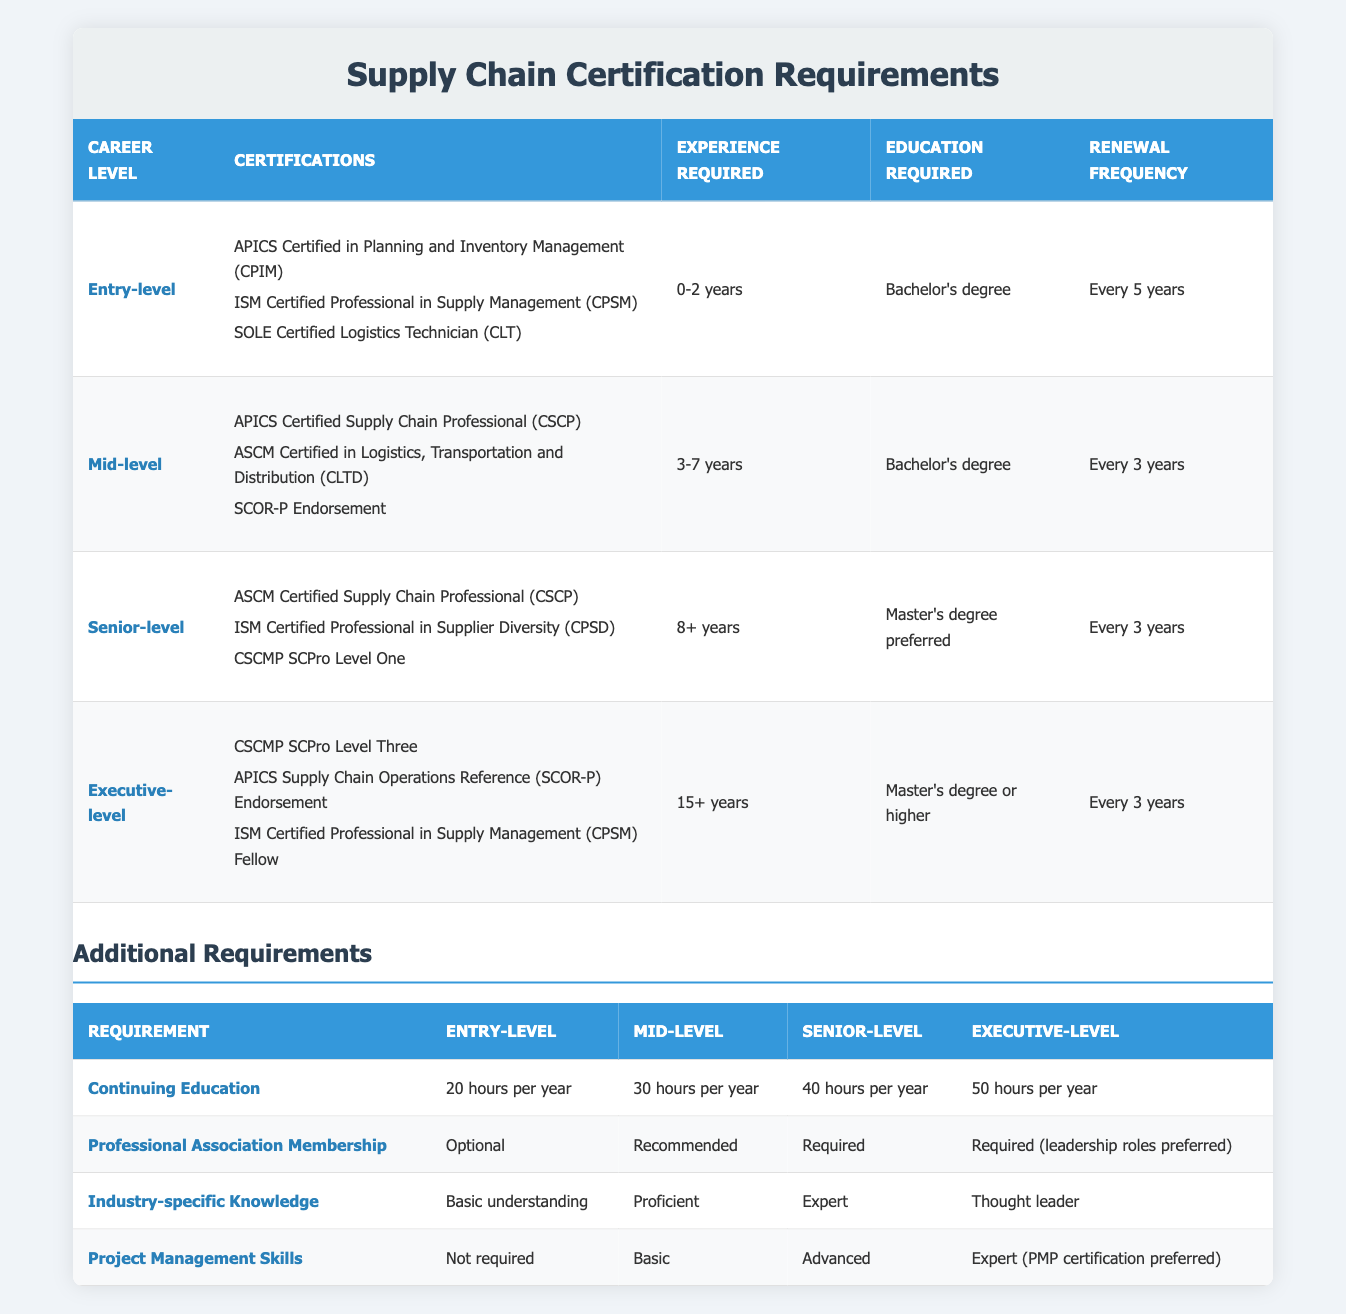What are the certifications required for an entry-level position? The table lists three certifications for the entry-level position: APICS Certified in Planning and Inventory Management (CPIM), ISM Certified Professional in Supply Management (CPSM), and SOLE Certified Logistics Technician (CLT).
Answer: APICS CPIM, ISM CPSM, SOLE CLT How often do senior-level certifications need to be renewed? According to the table, senior-level certifications need to be renewed every 3 years.
Answer: Every 3 years Is a master's degree required for all executive-level positions? The table indicates that a master's degree or higher is required for executive-level positions, but it does not specify that it is required for all executive-level positions. It states "Master's degree or higher," implying flexibility in education requirements for some roles.
Answer: No Which position requires the highest number of continuing education hours annually? The table shows the following: Entry-level requires 20 hours, Mid-level requires 30 hours, Senior-level requires 40 hours, and Executive-level requires 50 hours. Thus, Executive-level requires the highest number of continuing education hours.
Answer: Executive-level What is the minimum experience required for mid-level certifications? The table specifies that mid-level certifications require 3-7 years of experience. Thus, the minimum experience required is 3 years.
Answer: 3 years Do entry-level positions require any project management skills? As per the table, entry-level positions do not require project management skills, indicated by "Not required."
Answer: No Which certification is common between mid-level and senior-level positions? The certification "ASCM Certified Supply Chain Professional (CSCP)" is listed as a requirement for both mid-level and senior-level positions, demonstrating its relevance at multiple career stages.
Answer: ASCM CSCP What is the average renewal frequency for certifications across all levels? The renewal frequencies are: Entry-level (5 years), Mid-level (3 years), Senior-level (3 years), Executive-level (3 years). Sum these values (5 + 3 + 3 + 3 = 14) and divide by 4 to find the average, which is 14/4 = 3.5 years.
Answer: 3.5 years What type of project management skills are expected from a senior-level position? The table states that senior-level positions require "Advanced" project management skills, indicating a higher competency level in this area.
Answer: Advanced 